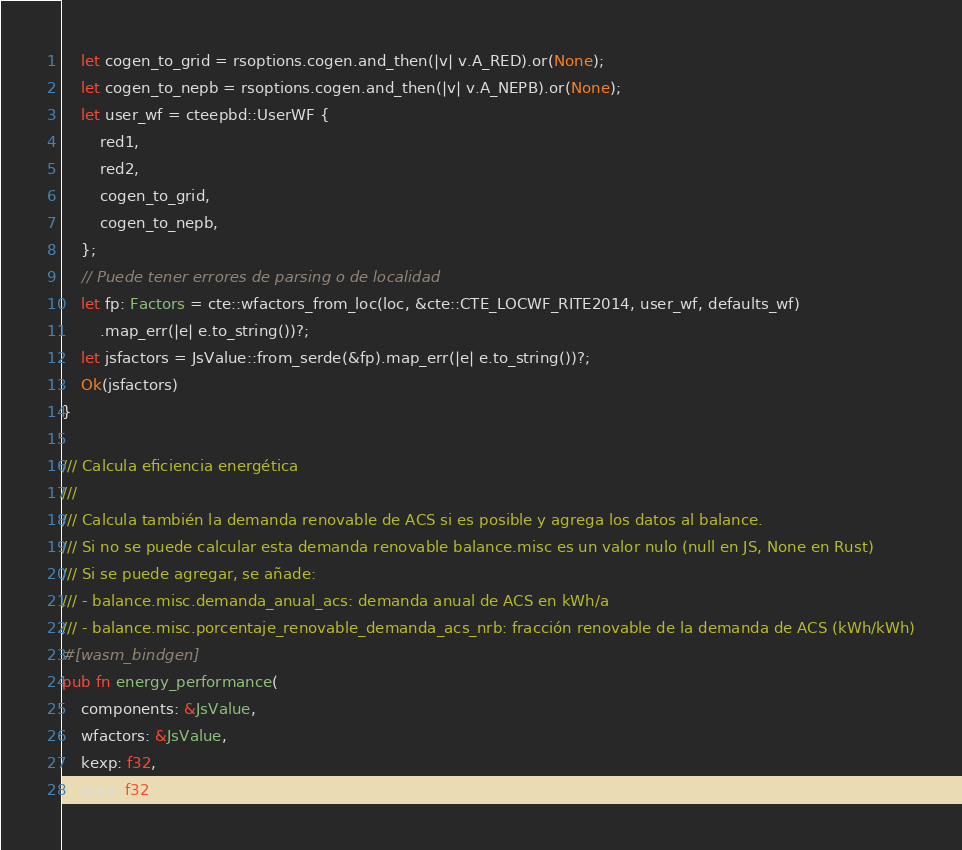Convert code to text. <code><loc_0><loc_0><loc_500><loc_500><_Rust_>    let cogen_to_grid = rsoptions.cogen.and_then(|v| v.A_RED).or(None);
    let cogen_to_nepb = rsoptions.cogen.and_then(|v| v.A_NEPB).or(None);
    let user_wf = cteepbd::UserWF {
        red1,
        red2,
        cogen_to_grid,
        cogen_to_nepb,
    };
    // Puede tener errores de parsing o de localidad
    let fp: Factors = cte::wfactors_from_loc(loc, &cte::CTE_LOCWF_RITE2014, user_wf, defaults_wf)
        .map_err(|e| e.to_string())?;
    let jsfactors = JsValue::from_serde(&fp).map_err(|e| e.to_string())?;
    Ok(jsfactors)
}

/// Calcula eficiencia energética
///
/// Calcula también la demanda renovable de ACS si es posible y agrega los datos al balance.
/// Si no se puede calcular esta demanda renovable balance.misc es un valor nulo (null en JS, None en Rust)
/// Si se puede agregar, se añade:
/// - balance.misc.demanda_anual_acs: demanda anual de ACS en kWh/a
/// - balance.misc.porcentaje_renovable_demanda_acs_nrb: fracción renovable de la demanda de ACS (kWh/kWh)
#[wasm_bindgen]
pub fn energy_performance(
    components: &JsValue,
    wfactors: &JsValue,
    kexp: f32,
    area: f32,</code> 